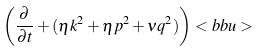Convert formula to latex. <formula><loc_0><loc_0><loc_500><loc_500>\left ( \frac { \partial } { \partial t } + ( \eta k ^ { 2 } + \eta p ^ { 2 } + \nu q ^ { 2 } ) \right ) < b b u ></formula> 